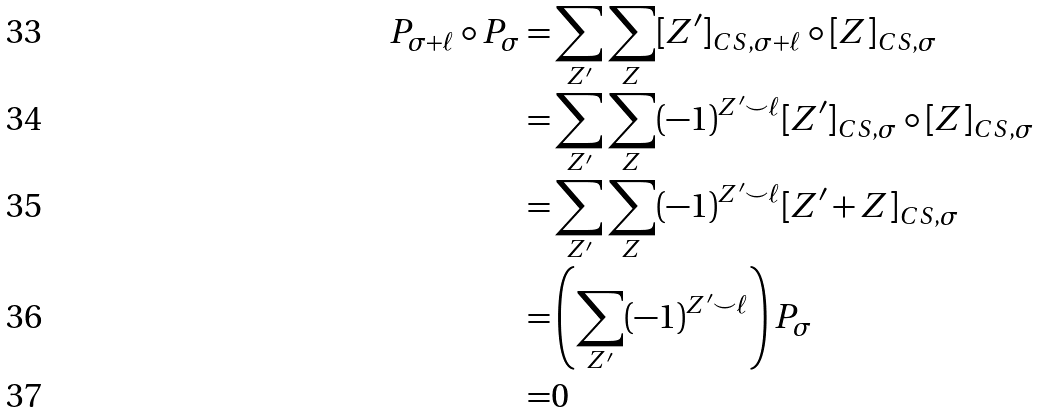<formula> <loc_0><loc_0><loc_500><loc_500>P _ { \sigma + \ell } \circ P _ { \sigma } = & \sum _ { Z ^ { \prime } } \sum _ { Z } [ Z ^ { \prime } ] _ { C S , \sigma + \ell } \circ [ Z ] _ { C S , \sigma } \\ = & \sum _ { Z ^ { \prime } } \sum _ { Z } ( - 1 ) ^ { Z ^ { \prime } \smile \ell } [ Z ^ { \prime } ] _ { C S , \sigma } \circ [ Z ] _ { C S , \sigma } \\ = & \sum _ { Z ^ { \prime } } \sum _ { Z } ( - 1 ) ^ { Z ^ { \prime } \smile \ell } [ Z ^ { \prime } + Z ] _ { C S , \sigma } \\ = & \left ( \sum _ { Z ^ { \prime } } ( - 1 ) ^ { Z ^ { \prime } \smile \ell } \right ) P _ { \sigma } \\ = & 0</formula> 